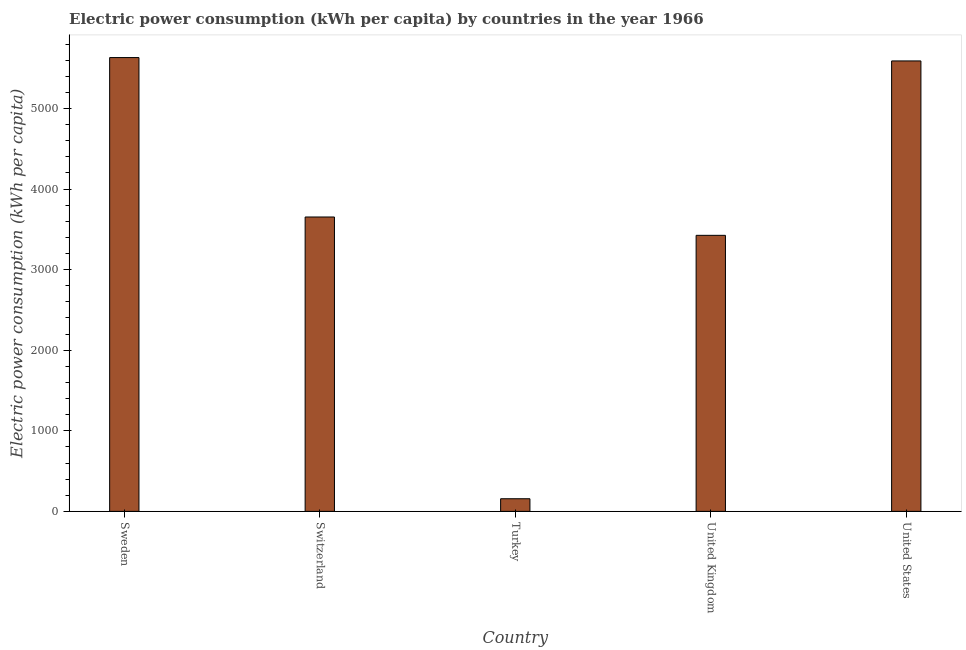Does the graph contain grids?
Your response must be concise. No. What is the title of the graph?
Give a very brief answer. Electric power consumption (kWh per capita) by countries in the year 1966. What is the label or title of the X-axis?
Keep it short and to the point. Country. What is the label or title of the Y-axis?
Offer a very short reply. Electric power consumption (kWh per capita). What is the electric power consumption in Sweden?
Give a very brief answer. 5632.19. Across all countries, what is the maximum electric power consumption?
Offer a terse response. 5632.19. Across all countries, what is the minimum electric power consumption?
Provide a succinct answer. 156.63. In which country was the electric power consumption minimum?
Give a very brief answer. Turkey. What is the sum of the electric power consumption?
Ensure brevity in your answer.  1.85e+04. What is the difference between the electric power consumption in United Kingdom and United States?
Your response must be concise. -2164.53. What is the average electric power consumption per country?
Offer a terse response. 3691.68. What is the median electric power consumption?
Your answer should be very brief. 3653.43. In how many countries, is the electric power consumption greater than 1000 kWh per capita?
Your answer should be very brief. 4. What is the ratio of the electric power consumption in Switzerland to that in Turkey?
Provide a succinct answer. 23.32. Is the electric power consumption in Sweden less than that in United Kingdom?
Your answer should be very brief. No. Is the difference between the electric power consumption in Turkey and United States greater than the difference between any two countries?
Your response must be concise. No. What is the difference between the highest and the second highest electric power consumption?
Offer a very short reply. 41.86. What is the difference between the highest and the lowest electric power consumption?
Provide a succinct answer. 5475.56. In how many countries, is the electric power consumption greater than the average electric power consumption taken over all countries?
Ensure brevity in your answer.  2. How many countries are there in the graph?
Give a very brief answer. 5. Are the values on the major ticks of Y-axis written in scientific E-notation?
Ensure brevity in your answer.  No. What is the Electric power consumption (kWh per capita) of Sweden?
Give a very brief answer. 5632.19. What is the Electric power consumption (kWh per capita) in Switzerland?
Your response must be concise. 3653.43. What is the Electric power consumption (kWh per capita) of Turkey?
Make the answer very short. 156.63. What is the Electric power consumption (kWh per capita) of United Kingdom?
Provide a succinct answer. 3425.8. What is the Electric power consumption (kWh per capita) of United States?
Offer a terse response. 5590.33. What is the difference between the Electric power consumption (kWh per capita) in Sweden and Switzerland?
Offer a terse response. 1978.76. What is the difference between the Electric power consumption (kWh per capita) in Sweden and Turkey?
Provide a succinct answer. 5475.56. What is the difference between the Electric power consumption (kWh per capita) in Sweden and United Kingdom?
Your answer should be very brief. 2206.39. What is the difference between the Electric power consumption (kWh per capita) in Sweden and United States?
Provide a succinct answer. 41.86. What is the difference between the Electric power consumption (kWh per capita) in Switzerland and Turkey?
Make the answer very short. 3496.8. What is the difference between the Electric power consumption (kWh per capita) in Switzerland and United Kingdom?
Offer a terse response. 227.63. What is the difference between the Electric power consumption (kWh per capita) in Switzerland and United States?
Ensure brevity in your answer.  -1936.9. What is the difference between the Electric power consumption (kWh per capita) in Turkey and United Kingdom?
Give a very brief answer. -3269.17. What is the difference between the Electric power consumption (kWh per capita) in Turkey and United States?
Provide a succinct answer. -5433.7. What is the difference between the Electric power consumption (kWh per capita) in United Kingdom and United States?
Offer a terse response. -2164.53. What is the ratio of the Electric power consumption (kWh per capita) in Sweden to that in Switzerland?
Provide a short and direct response. 1.54. What is the ratio of the Electric power consumption (kWh per capita) in Sweden to that in Turkey?
Offer a very short reply. 35.96. What is the ratio of the Electric power consumption (kWh per capita) in Sweden to that in United Kingdom?
Give a very brief answer. 1.64. What is the ratio of the Electric power consumption (kWh per capita) in Sweden to that in United States?
Offer a terse response. 1.01. What is the ratio of the Electric power consumption (kWh per capita) in Switzerland to that in Turkey?
Your answer should be very brief. 23.32. What is the ratio of the Electric power consumption (kWh per capita) in Switzerland to that in United Kingdom?
Make the answer very short. 1.07. What is the ratio of the Electric power consumption (kWh per capita) in Switzerland to that in United States?
Your answer should be compact. 0.65. What is the ratio of the Electric power consumption (kWh per capita) in Turkey to that in United Kingdom?
Your answer should be compact. 0.05. What is the ratio of the Electric power consumption (kWh per capita) in Turkey to that in United States?
Provide a succinct answer. 0.03. What is the ratio of the Electric power consumption (kWh per capita) in United Kingdom to that in United States?
Your answer should be very brief. 0.61. 